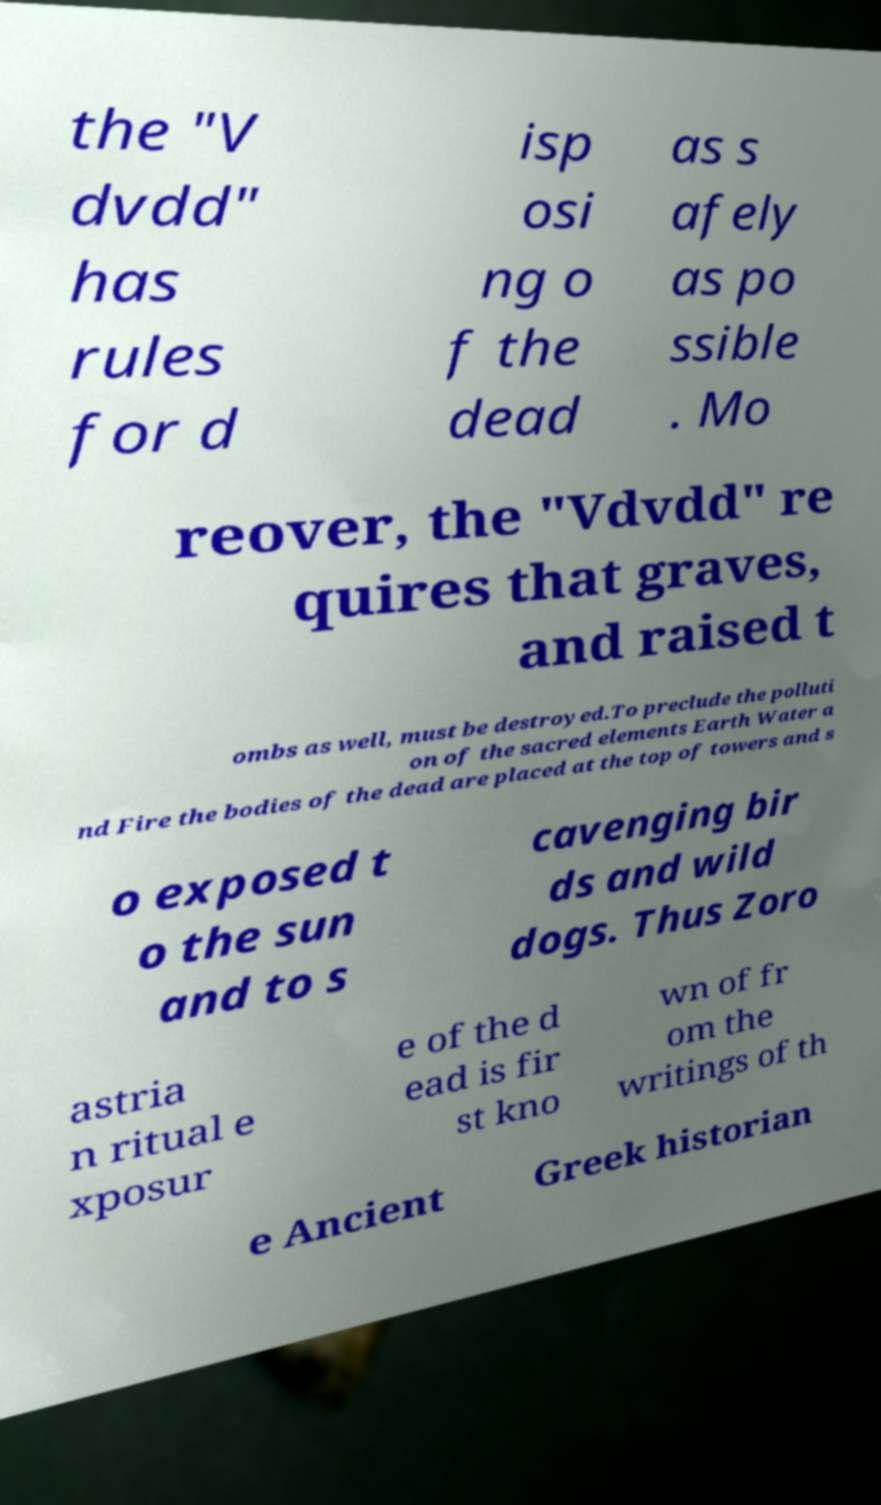Please read and relay the text visible in this image. What does it say? the "V dvdd" has rules for d isp osi ng o f the dead as s afely as po ssible . Mo reover, the "Vdvdd" re quires that graves, and raised t ombs as well, must be destroyed.To preclude the polluti on of the sacred elements Earth Water a nd Fire the bodies of the dead are placed at the top of towers and s o exposed t o the sun and to s cavenging bir ds and wild dogs. Thus Zoro astria n ritual e xposur e of the d ead is fir st kno wn of fr om the writings of th e Ancient Greek historian 